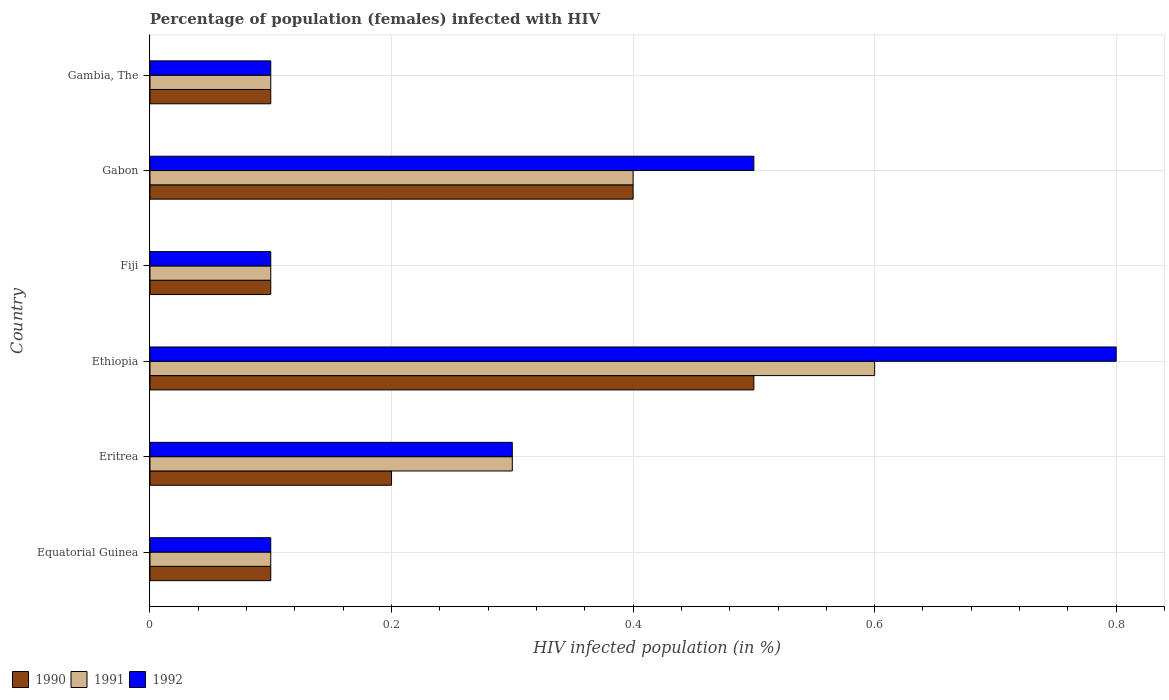How many different coloured bars are there?
Give a very brief answer. 3. How many groups of bars are there?
Make the answer very short. 6. Are the number of bars per tick equal to the number of legend labels?
Give a very brief answer. Yes. Are the number of bars on each tick of the Y-axis equal?
Ensure brevity in your answer.  Yes. How many bars are there on the 6th tick from the top?
Your answer should be very brief. 3. What is the label of the 3rd group of bars from the top?
Keep it short and to the point. Fiji. What is the percentage of HIV infected female population in 1990 in Gabon?
Ensure brevity in your answer.  0.4. Across all countries, what is the minimum percentage of HIV infected female population in 1990?
Give a very brief answer. 0.1. In which country was the percentage of HIV infected female population in 1992 maximum?
Provide a succinct answer. Ethiopia. In which country was the percentage of HIV infected female population in 1992 minimum?
Provide a short and direct response. Equatorial Guinea. What is the total percentage of HIV infected female population in 1990 in the graph?
Offer a terse response. 1.4. What is the difference between the percentage of HIV infected female population in 1990 in Eritrea and that in Fiji?
Give a very brief answer. 0.1. What is the difference between the percentage of HIV infected female population in 1992 in Gabon and the percentage of HIV infected female population in 1990 in Ethiopia?
Provide a short and direct response. 0. What is the average percentage of HIV infected female population in 1991 per country?
Keep it short and to the point. 0.27. What is the difference between the percentage of HIV infected female population in 1991 and percentage of HIV infected female population in 1990 in Eritrea?
Your response must be concise. 0.1. What is the ratio of the percentage of HIV infected female population in 1991 in Eritrea to that in Ethiopia?
Ensure brevity in your answer.  0.5. What is the difference between the highest and the second highest percentage of HIV infected female population in 1991?
Your answer should be compact. 0.2. In how many countries, is the percentage of HIV infected female population in 1990 greater than the average percentage of HIV infected female population in 1990 taken over all countries?
Make the answer very short. 2. Is the sum of the percentage of HIV infected female population in 1992 in Eritrea and Ethiopia greater than the maximum percentage of HIV infected female population in 1991 across all countries?
Your answer should be compact. Yes. What does the 1st bar from the bottom in Eritrea represents?
Make the answer very short. 1990. How many bars are there?
Ensure brevity in your answer.  18. What is the difference between two consecutive major ticks on the X-axis?
Provide a succinct answer. 0.2. Does the graph contain grids?
Offer a terse response. Yes. How many legend labels are there?
Your answer should be very brief. 3. What is the title of the graph?
Ensure brevity in your answer.  Percentage of population (females) infected with HIV. What is the label or title of the X-axis?
Give a very brief answer. HIV infected population (in %). What is the HIV infected population (in %) of 1990 in Eritrea?
Provide a short and direct response. 0.2. What is the HIV infected population (in %) of 1992 in Eritrea?
Offer a very short reply. 0.3. What is the HIV infected population (in %) of 1990 in Fiji?
Offer a very short reply. 0.1. What is the HIV infected population (in %) in 1991 in Fiji?
Ensure brevity in your answer.  0.1. What is the HIV infected population (in %) in 1992 in Fiji?
Offer a very short reply. 0.1. What is the HIV infected population (in %) in 1992 in Gabon?
Offer a terse response. 0.5. What is the HIV infected population (in %) in 1990 in Gambia, The?
Keep it short and to the point. 0.1. What is the HIV infected population (in %) in 1991 in Gambia, The?
Your answer should be compact. 0.1. Across all countries, what is the maximum HIV infected population (in %) in 1991?
Provide a succinct answer. 0.6. Across all countries, what is the maximum HIV infected population (in %) of 1992?
Keep it short and to the point. 0.8. What is the total HIV infected population (in %) of 1991 in the graph?
Make the answer very short. 1.6. What is the difference between the HIV infected population (in %) of 1992 in Equatorial Guinea and that in Eritrea?
Offer a terse response. -0.2. What is the difference between the HIV infected population (in %) of 1990 in Equatorial Guinea and that in Ethiopia?
Offer a terse response. -0.4. What is the difference between the HIV infected population (in %) in 1991 in Equatorial Guinea and that in Ethiopia?
Ensure brevity in your answer.  -0.5. What is the difference between the HIV infected population (in %) in 1990 in Equatorial Guinea and that in Fiji?
Provide a succinct answer. 0. What is the difference between the HIV infected population (in %) of 1992 in Equatorial Guinea and that in Fiji?
Make the answer very short. 0. What is the difference between the HIV infected population (in %) of 1992 in Equatorial Guinea and that in Gabon?
Make the answer very short. -0.4. What is the difference between the HIV infected population (in %) of 1992 in Equatorial Guinea and that in Gambia, The?
Offer a terse response. 0. What is the difference between the HIV infected population (in %) of 1992 in Eritrea and that in Ethiopia?
Your response must be concise. -0.5. What is the difference between the HIV infected population (in %) in 1990 in Eritrea and that in Fiji?
Offer a very short reply. 0.1. What is the difference between the HIV infected population (in %) of 1991 in Eritrea and that in Fiji?
Give a very brief answer. 0.2. What is the difference between the HIV infected population (in %) in 1991 in Eritrea and that in Gabon?
Your answer should be compact. -0.1. What is the difference between the HIV infected population (in %) of 1991 in Eritrea and that in Gambia, The?
Keep it short and to the point. 0.2. What is the difference between the HIV infected population (in %) in 1992 in Eritrea and that in Gambia, The?
Keep it short and to the point. 0.2. What is the difference between the HIV infected population (in %) of 1991 in Ethiopia and that in Fiji?
Your answer should be compact. 0.5. What is the difference between the HIV infected population (in %) in 1992 in Ethiopia and that in Fiji?
Offer a terse response. 0.7. What is the difference between the HIV infected population (in %) of 1990 in Ethiopia and that in Gabon?
Your answer should be compact. 0.1. What is the difference between the HIV infected population (in %) of 1992 in Ethiopia and that in Gabon?
Ensure brevity in your answer.  0.3. What is the difference between the HIV infected population (in %) in 1992 in Ethiopia and that in Gambia, The?
Your response must be concise. 0.7. What is the difference between the HIV infected population (in %) of 1990 in Fiji and that in Gabon?
Make the answer very short. -0.3. What is the difference between the HIV infected population (in %) of 1991 in Fiji and that in Gabon?
Provide a succinct answer. -0.3. What is the difference between the HIV infected population (in %) in 1992 in Fiji and that in Gabon?
Your answer should be compact. -0.4. What is the difference between the HIV infected population (in %) of 1990 in Fiji and that in Gambia, The?
Provide a succinct answer. 0. What is the difference between the HIV infected population (in %) of 1991 in Fiji and that in Gambia, The?
Make the answer very short. 0. What is the difference between the HIV infected population (in %) in 1992 in Fiji and that in Gambia, The?
Offer a terse response. 0. What is the difference between the HIV infected population (in %) of 1991 in Gabon and that in Gambia, The?
Provide a short and direct response. 0.3. What is the difference between the HIV infected population (in %) in 1990 in Equatorial Guinea and the HIV infected population (in %) in 1992 in Eritrea?
Provide a succinct answer. -0.2. What is the difference between the HIV infected population (in %) in 1990 in Equatorial Guinea and the HIV infected population (in %) in 1992 in Fiji?
Offer a very short reply. 0. What is the difference between the HIV infected population (in %) of 1991 in Equatorial Guinea and the HIV infected population (in %) of 1992 in Fiji?
Make the answer very short. 0. What is the difference between the HIV infected population (in %) in 1990 in Equatorial Guinea and the HIV infected population (in %) in 1991 in Gabon?
Your answer should be compact. -0.3. What is the difference between the HIV infected population (in %) in 1990 in Equatorial Guinea and the HIV infected population (in %) in 1992 in Gambia, The?
Give a very brief answer. 0. What is the difference between the HIV infected population (in %) of 1991 in Equatorial Guinea and the HIV infected population (in %) of 1992 in Gambia, The?
Your response must be concise. 0. What is the difference between the HIV infected population (in %) of 1990 in Eritrea and the HIV infected population (in %) of 1991 in Fiji?
Offer a terse response. 0.1. What is the difference between the HIV infected population (in %) of 1990 in Eritrea and the HIV infected population (in %) of 1992 in Fiji?
Make the answer very short. 0.1. What is the difference between the HIV infected population (in %) of 1991 in Eritrea and the HIV infected population (in %) of 1992 in Fiji?
Give a very brief answer. 0.2. What is the difference between the HIV infected population (in %) in 1991 in Eritrea and the HIV infected population (in %) in 1992 in Gabon?
Give a very brief answer. -0.2. What is the difference between the HIV infected population (in %) in 1990 in Eritrea and the HIV infected population (in %) in 1991 in Gambia, The?
Provide a short and direct response. 0.1. What is the difference between the HIV infected population (in %) of 1991 in Eritrea and the HIV infected population (in %) of 1992 in Gambia, The?
Ensure brevity in your answer.  0.2. What is the difference between the HIV infected population (in %) in 1990 in Ethiopia and the HIV infected population (in %) in 1991 in Fiji?
Give a very brief answer. 0.4. What is the difference between the HIV infected population (in %) of 1990 in Ethiopia and the HIV infected population (in %) of 1991 in Gabon?
Give a very brief answer. 0.1. What is the difference between the HIV infected population (in %) of 1990 in Ethiopia and the HIV infected population (in %) of 1992 in Gabon?
Keep it short and to the point. 0. What is the difference between the HIV infected population (in %) in 1990 in Ethiopia and the HIV infected population (in %) in 1991 in Gambia, The?
Give a very brief answer. 0.4. What is the difference between the HIV infected population (in %) in 1990 in Ethiopia and the HIV infected population (in %) in 1992 in Gambia, The?
Your response must be concise. 0.4. What is the difference between the HIV infected population (in %) in 1991 in Ethiopia and the HIV infected population (in %) in 1992 in Gambia, The?
Provide a succinct answer. 0.5. What is the difference between the HIV infected population (in %) in 1990 in Fiji and the HIV infected population (in %) in 1991 in Gabon?
Ensure brevity in your answer.  -0.3. What is the difference between the HIV infected population (in %) in 1990 in Fiji and the HIV infected population (in %) in 1992 in Gabon?
Ensure brevity in your answer.  -0.4. What is the difference between the HIV infected population (in %) in 1990 in Fiji and the HIV infected population (in %) in 1992 in Gambia, The?
Make the answer very short. 0. What is the difference between the HIV infected population (in %) of 1990 in Gabon and the HIV infected population (in %) of 1992 in Gambia, The?
Keep it short and to the point. 0.3. What is the average HIV infected population (in %) in 1990 per country?
Make the answer very short. 0.23. What is the average HIV infected population (in %) in 1991 per country?
Your answer should be compact. 0.27. What is the average HIV infected population (in %) of 1992 per country?
Provide a short and direct response. 0.32. What is the difference between the HIV infected population (in %) of 1990 and HIV infected population (in %) of 1992 in Equatorial Guinea?
Offer a terse response. 0. What is the difference between the HIV infected population (in %) in 1990 and HIV infected population (in %) in 1992 in Eritrea?
Give a very brief answer. -0.1. What is the difference between the HIV infected population (in %) in 1991 and HIV infected population (in %) in 1992 in Eritrea?
Your response must be concise. 0. What is the difference between the HIV infected population (in %) in 1990 and HIV infected population (in %) in 1992 in Ethiopia?
Keep it short and to the point. -0.3. What is the difference between the HIV infected population (in %) of 1990 and HIV infected population (in %) of 1992 in Gabon?
Give a very brief answer. -0.1. What is the difference between the HIV infected population (in %) of 1991 and HIV infected population (in %) of 1992 in Gabon?
Provide a short and direct response. -0.1. What is the difference between the HIV infected population (in %) of 1991 and HIV infected population (in %) of 1992 in Gambia, The?
Provide a succinct answer. 0. What is the ratio of the HIV infected population (in %) in 1990 in Equatorial Guinea to that in Eritrea?
Provide a short and direct response. 0.5. What is the ratio of the HIV infected population (in %) of 1992 in Equatorial Guinea to that in Ethiopia?
Offer a very short reply. 0.12. What is the ratio of the HIV infected population (in %) in 1991 in Equatorial Guinea to that in Fiji?
Make the answer very short. 1. What is the ratio of the HIV infected population (in %) in 1992 in Equatorial Guinea to that in Fiji?
Keep it short and to the point. 1. What is the ratio of the HIV infected population (in %) in 1991 in Equatorial Guinea to that in Gabon?
Your response must be concise. 0.25. What is the ratio of the HIV infected population (in %) of 1992 in Equatorial Guinea to that in Gabon?
Make the answer very short. 0.2. What is the ratio of the HIV infected population (in %) in 1990 in Equatorial Guinea to that in Gambia, The?
Offer a very short reply. 1. What is the ratio of the HIV infected population (in %) of 1992 in Eritrea to that in Ethiopia?
Your answer should be very brief. 0.38. What is the ratio of the HIV infected population (in %) of 1991 in Eritrea to that in Gabon?
Provide a succinct answer. 0.75. What is the ratio of the HIV infected population (in %) in 1992 in Eritrea to that in Gabon?
Your response must be concise. 0.6. What is the ratio of the HIV infected population (in %) in 1990 in Eritrea to that in Gambia, The?
Provide a succinct answer. 2. What is the ratio of the HIV infected population (in %) in 1992 in Eritrea to that in Gambia, The?
Keep it short and to the point. 3. What is the ratio of the HIV infected population (in %) of 1990 in Ethiopia to that in Fiji?
Your answer should be very brief. 5. What is the ratio of the HIV infected population (in %) in 1991 in Ethiopia to that in Gabon?
Ensure brevity in your answer.  1.5. What is the ratio of the HIV infected population (in %) of 1990 in Ethiopia to that in Gambia, The?
Offer a very short reply. 5. What is the ratio of the HIV infected population (in %) in 1991 in Ethiopia to that in Gambia, The?
Offer a very short reply. 6. What is the ratio of the HIV infected population (in %) in 1992 in Ethiopia to that in Gambia, The?
Make the answer very short. 8. What is the ratio of the HIV infected population (in %) of 1991 in Fiji to that in Gabon?
Keep it short and to the point. 0.25. What is the ratio of the HIV infected population (in %) of 1990 in Fiji to that in Gambia, The?
Provide a succinct answer. 1. What is the ratio of the HIV infected population (in %) of 1991 in Fiji to that in Gambia, The?
Offer a terse response. 1. What is the ratio of the HIV infected population (in %) of 1991 in Gabon to that in Gambia, The?
Your answer should be compact. 4. What is the ratio of the HIV infected population (in %) in 1992 in Gabon to that in Gambia, The?
Your answer should be very brief. 5. What is the difference between the highest and the lowest HIV infected population (in %) of 1990?
Keep it short and to the point. 0.4. 